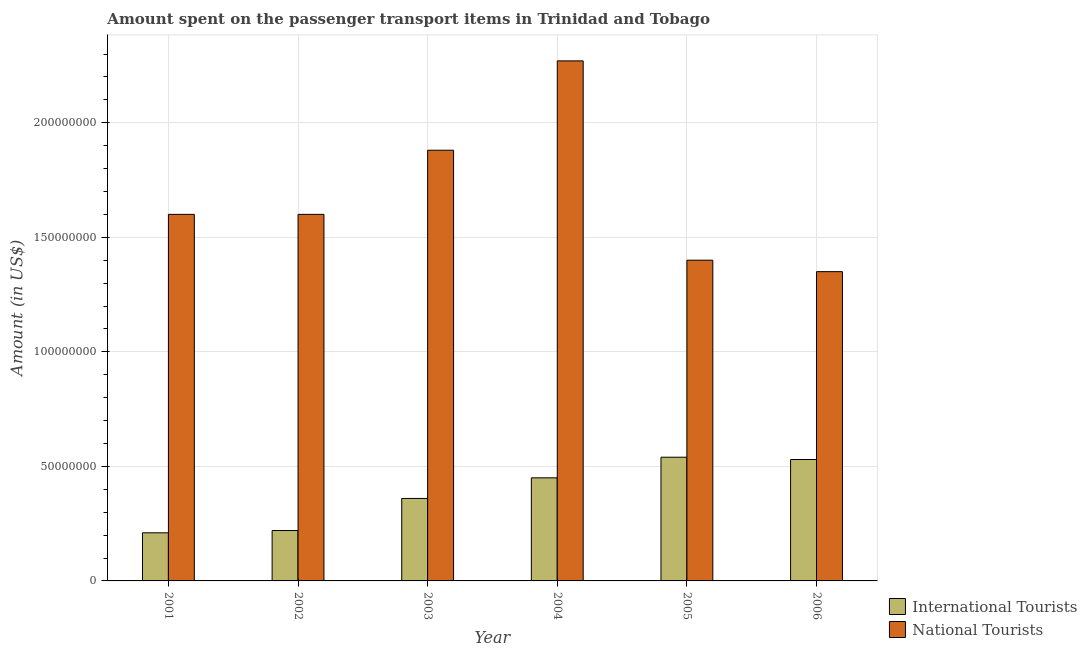Are the number of bars per tick equal to the number of legend labels?
Your response must be concise. Yes. How many bars are there on the 5th tick from the left?
Offer a very short reply. 2. How many bars are there on the 4th tick from the right?
Keep it short and to the point. 2. What is the label of the 1st group of bars from the left?
Your response must be concise. 2001. What is the amount spent on transport items of national tourists in 2006?
Your response must be concise. 1.35e+08. Across all years, what is the maximum amount spent on transport items of national tourists?
Your response must be concise. 2.27e+08. Across all years, what is the minimum amount spent on transport items of national tourists?
Give a very brief answer. 1.35e+08. What is the total amount spent on transport items of international tourists in the graph?
Your answer should be very brief. 2.31e+08. What is the difference between the amount spent on transport items of international tourists in 2002 and that in 2006?
Your answer should be compact. -3.10e+07. What is the difference between the amount spent on transport items of national tourists in 2005 and the amount spent on transport items of international tourists in 2004?
Your answer should be compact. -8.70e+07. What is the average amount spent on transport items of national tourists per year?
Provide a succinct answer. 1.68e+08. In the year 2006, what is the difference between the amount spent on transport items of international tourists and amount spent on transport items of national tourists?
Keep it short and to the point. 0. What is the ratio of the amount spent on transport items of national tourists in 2004 to that in 2006?
Provide a short and direct response. 1.68. Is the amount spent on transport items of national tourists in 2002 less than that in 2006?
Provide a short and direct response. No. Is the difference between the amount spent on transport items of national tourists in 2002 and 2006 greater than the difference between the amount spent on transport items of international tourists in 2002 and 2006?
Make the answer very short. No. What is the difference between the highest and the second highest amount spent on transport items of international tourists?
Offer a terse response. 1.00e+06. What is the difference between the highest and the lowest amount spent on transport items of international tourists?
Give a very brief answer. 3.30e+07. What does the 1st bar from the left in 2004 represents?
Offer a terse response. International Tourists. What does the 2nd bar from the right in 2005 represents?
Your response must be concise. International Tourists. How many years are there in the graph?
Offer a very short reply. 6. What is the difference between two consecutive major ticks on the Y-axis?
Your response must be concise. 5.00e+07. Does the graph contain any zero values?
Your answer should be very brief. No. Where does the legend appear in the graph?
Your response must be concise. Bottom right. How many legend labels are there?
Provide a short and direct response. 2. How are the legend labels stacked?
Provide a short and direct response. Vertical. What is the title of the graph?
Offer a terse response. Amount spent on the passenger transport items in Trinidad and Tobago. Does "Tetanus" appear as one of the legend labels in the graph?
Your response must be concise. No. What is the label or title of the X-axis?
Give a very brief answer. Year. What is the Amount (in US$) in International Tourists in 2001?
Offer a terse response. 2.10e+07. What is the Amount (in US$) in National Tourists in 2001?
Keep it short and to the point. 1.60e+08. What is the Amount (in US$) in International Tourists in 2002?
Ensure brevity in your answer.  2.20e+07. What is the Amount (in US$) in National Tourists in 2002?
Provide a succinct answer. 1.60e+08. What is the Amount (in US$) of International Tourists in 2003?
Offer a terse response. 3.60e+07. What is the Amount (in US$) in National Tourists in 2003?
Your answer should be very brief. 1.88e+08. What is the Amount (in US$) in International Tourists in 2004?
Make the answer very short. 4.50e+07. What is the Amount (in US$) of National Tourists in 2004?
Your response must be concise. 2.27e+08. What is the Amount (in US$) of International Tourists in 2005?
Give a very brief answer. 5.40e+07. What is the Amount (in US$) of National Tourists in 2005?
Make the answer very short. 1.40e+08. What is the Amount (in US$) in International Tourists in 2006?
Ensure brevity in your answer.  5.30e+07. What is the Amount (in US$) of National Tourists in 2006?
Ensure brevity in your answer.  1.35e+08. Across all years, what is the maximum Amount (in US$) of International Tourists?
Provide a succinct answer. 5.40e+07. Across all years, what is the maximum Amount (in US$) in National Tourists?
Your response must be concise. 2.27e+08. Across all years, what is the minimum Amount (in US$) of International Tourists?
Keep it short and to the point. 2.10e+07. Across all years, what is the minimum Amount (in US$) of National Tourists?
Your answer should be very brief. 1.35e+08. What is the total Amount (in US$) in International Tourists in the graph?
Your answer should be compact. 2.31e+08. What is the total Amount (in US$) in National Tourists in the graph?
Keep it short and to the point. 1.01e+09. What is the difference between the Amount (in US$) in International Tourists in 2001 and that in 2002?
Provide a succinct answer. -1.00e+06. What is the difference between the Amount (in US$) in National Tourists in 2001 and that in 2002?
Your answer should be very brief. 0. What is the difference between the Amount (in US$) in International Tourists in 2001 and that in 2003?
Keep it short and to the point. -1.50e+07. What is the difference between the Amount (in US$) of National Tourists in 2001 and that in 2003?
Your response must be concise. -2.80e+07. What is the difference between the Amount (in US$) of International Tourists in 2001 and that in 2004?
Make the answer very short. -2.40e+07. What is the difference between the Amount (in US$) in National Tourists in 2001 and that in 2004?
Provide a succinct answer. -6.70e+07. What is the difference between the Amount (in US$) of International Tourists in 2001 and that in 2005?
Offer a very short reply. -3.30e+07. What is the difference between the Amount (in US$) of National Tourists in 2001 and that in 2005?
Your response must be concise. 2.00e+07. What is the difference between the Amount (in US$) of International Tourists in 2001 and that in 2006?
Keep it short and to the point. -3.20e+07. What is the difference between the Amount (in US$) of National Tourists in 2001 and that in 2006?
Provide a short and direct response. 2.50e+07. What is the difference between the Amount (in US$) in International Tourists in 2002 and that in 2003?
Provide a succinct answer. -1.40e+07. What is the difference between the Amount (in US$) of National Tourists in 2002 and that in 2003?
Keep it short and to the point. -2.80e+07. What is the difference between the Amount (in US$) in International Tourists in 2002 and that in 2004?
Provide a short and direct response. -2.30e+07. What is the difference between the Amount (in US$) in National Tourists in 2002 and that in 2004?
Provide a succinct answer. -6.70e+07. What is the difference between the Amount (in US$) of International Tourists in 2002 and that in 2005?
Offer a terse response. -3.20e+07. What is the difference between the Amount (in US$) in International Tourists in 2002 and that in 2006?
Offer a terse response. -3.10e+07. What is the difference between the Amount (in US$) in National Tourists in 2002 and that in 2006?
Make the answer very short. 2.50e+07. What is the difference between the Amount (in US$) in International Tourists in 2003 and that in 2004?
Offer a terse response. -9.00e+06. What is the difference between the Amount (in US$) of National Tourists in 2003 and that in 2004?
Ensure brevity in your answer.  -3.90e+07. What is the difference between the Amount (in US$) in International Tourists in 2003 and that in 2005?
Give a very brief answer. -1.80e+07. What is the difference between the Amount (in US$) of National Tourists in 2003 and that in 2005?
Your answer should be compact. 4.80e+07. What is the difference between the Amount (in US$) in International Tourists in 2003 and that in 2006?
Ensure brevity in your answer.  -1.70e+07. What is the difference between the Amount (in US$) in National Tourists in 2003 and that in 2006?
Ensure brevity in your answer.  5.30e+07. What is the difference between the Amount (in US$) of International Tourists in 2004 and that in 2005?
Your answer should be compact. -9.00e+06. What is the difference between the Amount (in US$) in National Tourists in 2004 and that in 2005?
Give a very brief answer. 8.70e+07. What is the difference between the Amount (in US$) of International Tourists in 2004 and that in 2006?
Your response must be concise. -8.00e+06. What is the difference between the Amount (in US$) in National Tourists in 2004 and that in 2006?
Ensure brevity in your answer.  9.20e+07. What is the difference between the Amount (in US$) in International Tourists in 2005 and that in 2006?
Provide a succinct answer. 1.00e+06. What is the difference between the Amount (in US$) in International Tourists in 2001 and the Amount (in US$) in National Tourists in 2002?
Your answer should be very brief. -1.39e+08. What is the difference between the Amount (in US$) in International Tourists in 2001 and the Amount (in US$) in National Tourists in 2003?
Provide a short and direct response. -1.67e+08. What is the difference between the Amount (in US$) in International Tourists in 2001 and the Amount (in US$) in National Tourists in 2004?
Your response must be concise. -2.06e+08. What is the difference between the Amount (in US$) of International Tourists in 2001 and the Amount (in US$) of National Tourists in 2005?
Offer a very short reply. -1.19e+08. What is the difference between the Amount (in US$) in International Tourists in 2001 and the Amount (in US$) in National Tourists in 2006?
Offer a very short reply. -1.14e+08. What is the difference between the Amount (in US$) in International Tourists in 2002 and the Amount (in US$) in National Tourists in 2003?
Provide a succinct answer. -1.66e+08. What is the difference between the Amount (in US$) of International Tourists in 2002 and the Amount (in US$) of National Tourists in 2004?
Keep it short and to the point. -2.05e+08. What is the difference between the Amount (in US$) of International Tourists in 2002 and the Amount (in US$) of National Tourists in 2005?
Ensure brevity in your answer.  -1.18e+08. What is the difference between the Amount (in US$) in International Tourists in 2002 and the Amount (in US$) in National Tourists in 2006?
Make the answer very short. -1.13e+08. What is the difference between the Amount (in US$) in International Tourists in 2003 and the Amount (in US$) in National Tourists in 2004?
Make the answer very short. -1.91e+08. What is the difference between the Amount (in US$) of International Tourists in 2003 and the Amount (in US$) of National Tourists in 2005?
Ensure brevity in your answer.  -1.04e+08. What is the difference between the Amount (in US$) in International Tourists in 2003 and the Amount (in US$) in National Tourists in 2006?
Offer a very short reply. -9.90e+07. What is the difference between the Amount (in US$) in International Tourists in 2004 and the Amount (in US$) in National Tourists in 2005?
Offer a terse response. -9.50e+07. What is the difference between the Amount (in US$) of International Tourists in 2004 and the Amount (in US$) of National Tourists in 2006?
Keep it short and to the point. -9.00e+07. What is the difference between the Amount (in US$) of International Tourists in 2005 and the Amount (in US$) of National Tourists in 2006?
Make the answer very short. -8.10e+07. What is the average Amount (in US$) in International Tourists per year?
Your response must be concise. 3.85e+07. What is the average Amount (in US$) of National Tourists per year?
Offer a very short reply. 1.68e+08. In the year 2001, what is the difference between the Amount (in US$) in International Tourists and Amount (in US$) in National Tourists?
Ensure brevity in your answer.  -1.39e+08. In the year 2002, what is the difference between the Amount (in US$) in International Tourists and Amount (in US$) in National Tourists?
Your answer should be compact. -1.38e+08. In the year 2003, what is the difference between the Amount (in US$) of International Tourists and Amount (in US$) of National Tourists?
Give a very brief answer. -1.52e+08. In the year 2004, what is the difference between the Amount (in US$) of International Tourists and Amount (in US$) of National Tourists?
Make the answer very short. -1.82e+08. In the year 2005, what is the difference between the Amount (in US$) in International Tourists and Amount (in US$) in National Tourists?
Keep it short and to the point. -8.60e+07. In the year 2006, what is the difference between the Amount (in US$) in International Tourists and Amount (in US$) in National Tourists?
Provide a short and direct response. -8.20e+07. What is the ratio of the Amount (in US$) in International Tourists in 2001 to that in 2002?
Provide a succinct answer. 0.95. What is the ratio of the Amount (in US$) of National Tourists in 2001 to that in 2002?
Offer a terse response. 1. What is the ratio of the Amount (in US$) of International Tourists in 2001 to that in 2003?
Ensure brevity in your answer.  0.58. What is the ratio of the Amount (in US$) in National Tourists in 2001 to that in 2003?
Ensure brevity in your answer.  0.85. What is the ratio of the Amount (in US$) of International Tourists in 2001 to that in 2004?
Offer a very short reply. 0.47. What is the ratio of the Amount (in US$) in National Tourists in 2001 to that in 2004?
Keep it short and to the point. 0.7. What is the ratio of the Amount (in US$) of International Tourists in 2001 to that in 2005?
Provide a succinct answer. 0.39. What is the ratio of the Amount (in US$) of National Tourists in 2001 to that in 2005?
Ensure brevity in your answer.  1.14. What is the ratio of the Amount (in US$) in International Tourists in 2001 to that in 2006?
Make the answer very short. 0.4. What is the ratio of the Amount (in US$) of National Tourists in 2001 to that in 2006?
Your response must be concise. 1.19. What is the ratio of the Amount (in US$) of International Tourists in 2002 to that in 2003?
Your response must be concise. 0.61. What is the ratio of the Amount (in US$) in National Tourists in 2002 to that in 2003?
Keep it short and to the point. 0.85. What is the ratio of the Amount (in US$) of International Tourists in 2002 to that in 2004?
Your answer should be very brief. 0.49. What is the ratio of the Amount (in US$) in National Tourists in 2002 to that in 2004?
Provide a short and direct response. 0.7. What is the ratio of the Amount (in US$) in International Tourists in 2002 to that in 2005?
Make the answer very short. 0.41. What is the ratio of the Amount (in US$) of International Tourists in 2002 to that in 2006?
Offer a terse response. 0.42. What is the ratio of the Amount (in US$) of National Tourists in 2002 to that in 2006?
Make the answer very short. 1.19. What is the ratio of the Amount (in US$) of National Tourists in 2003 to that in 2004?
Provide a short and direct response. 0.83. What is the ratio of the Amount (in US$) of International Tourists in 2003 to that in 2005?
Provide a succinct answer. 0.67. What is the ratio of the Amount (in US$) in National Tourists in 2003 to that in 2005?
Provide a short and direct response. 1.34. What is the ratio of the Amount (in US$) of International Tourists in 2003 to that in 2006?
Keep it short and to the point. 0.68. What is the ratio of the Amount (in US$) in National Tourists in 2003 to that in 2006?
Offer a very short reply. 1.39. What is the ratio of the Amount (in US$) in National Tourists in 2004 to that in 2005?
Provide a short and direct response. 1.62. What is the ratio of the Amount (in US$) in International Tourists in 2004 to that in 2006?
Your answer should be compact. 0.85. What is the ratio of the Amount (in US$) in National Tourists in 2004 to that in 2006?
Your answer should be compact. 1.68. What is the ratio of the Amount (in US$) in International Tourists in 2005 to that in 2006?
Your answer should be compact. 1.02. What is the difference between the highest and the second highest Amount (in US$) in National Tourists?
Ensure brevity in your answer.  3.90e+07. What is the difference between the highest and the lowest Amount (in US$) in International Tourists?
Provide a succinct answer. 3.30e+07. What is the difference between the highest and the lowest Amount (in US$) of National Tourists?
Offer a terse response. 9.20e+07. 